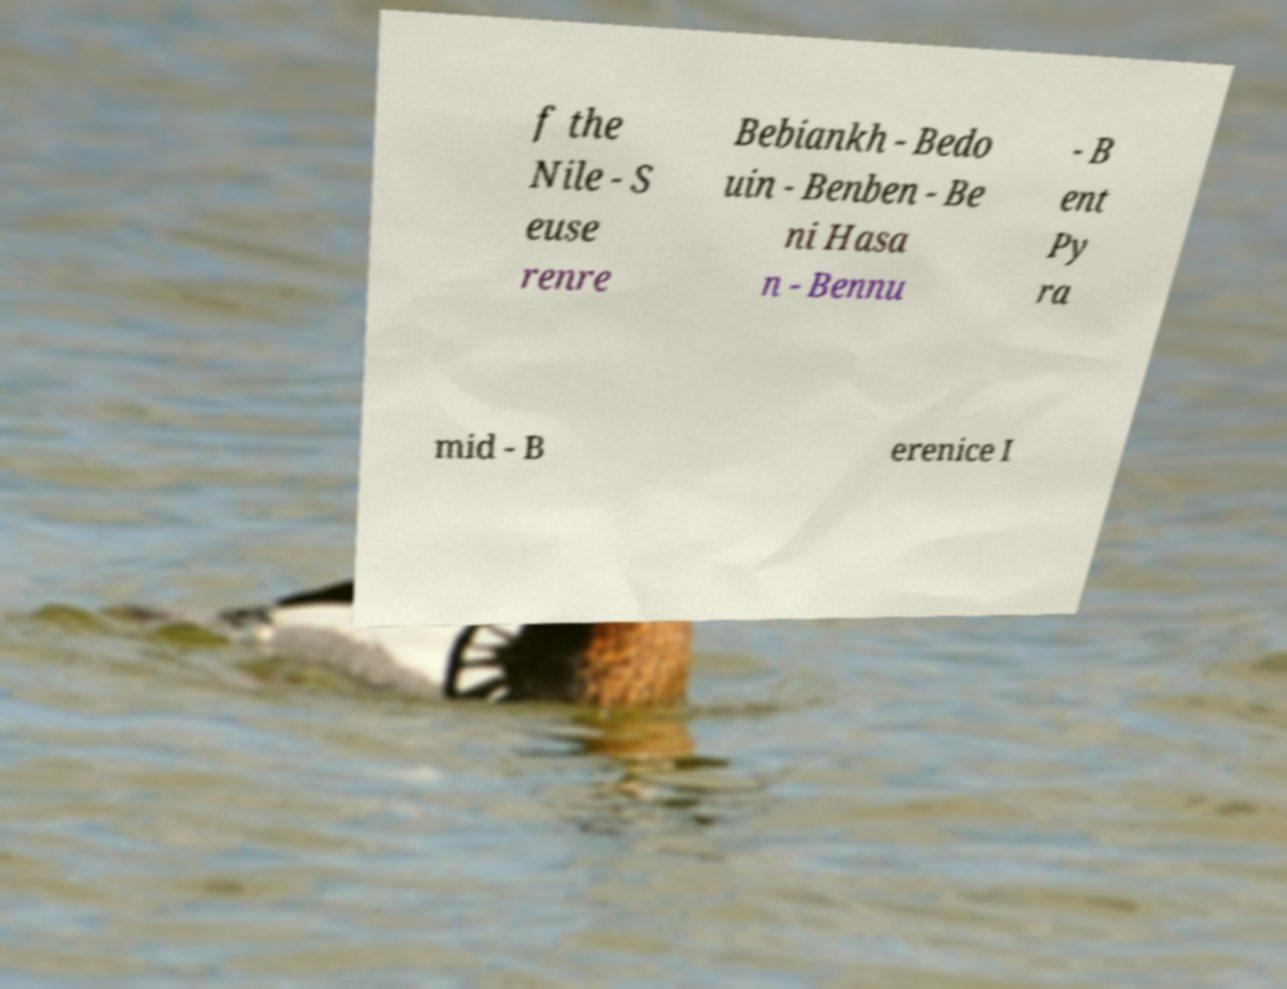Please identify and transcribe the text found in this image. f the Nile - S euse renre Bebiankh - Bedo uin - Benben - Be ni Hasa n - Bennu - B ent Py ra mid - B erenice I 